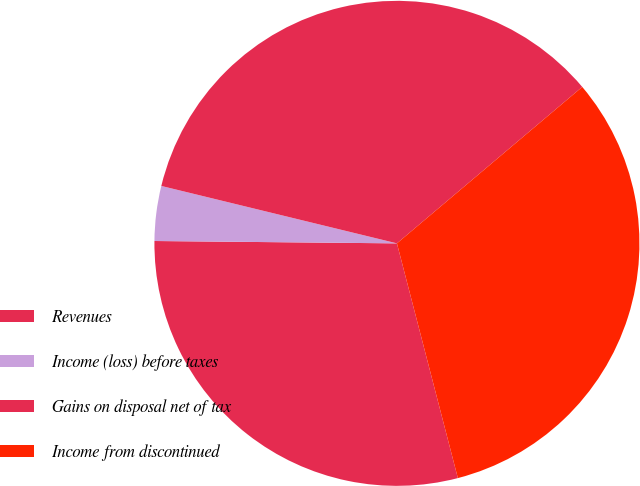<chart> <loc_0><loc_0><loc_500><loc_500><pie_chart><fcel>Revenues<fcel>Income (loss) before taxes<fcel>Gains on disposal net of tax<fcel>Income from discontinued<nl><fcel>29.2%<fcel>3.65%<fcel>35.04%<fcel>32.12%<nl></chart> 